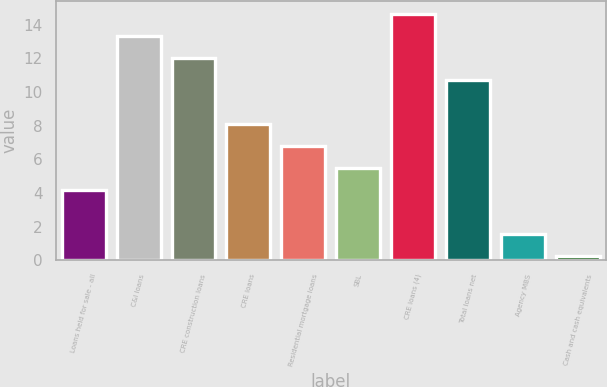Convert chart. <chart><loc_0><loc_0><loc_500><loc_500><bar_chart><fcel>Loans held for sale - all<fcel>C&I loans<fcel>CRE construction loans<fcel>CRE loans<fcel>Residential mortgage loans<fcel>SBL<fcel>CRE loans (4)<fcel>Total loans net<fcel>Agency MBS<fcel>Cash and cash equivalents<nl><fcel>4.17<fcel>13.34<fcel>12.03<fcel>8.1<fcel>6.79<fcel>5.48<fcel>14.65<fcel>10.72<fcel>1.55<fcel>0.24<nl></chart> 